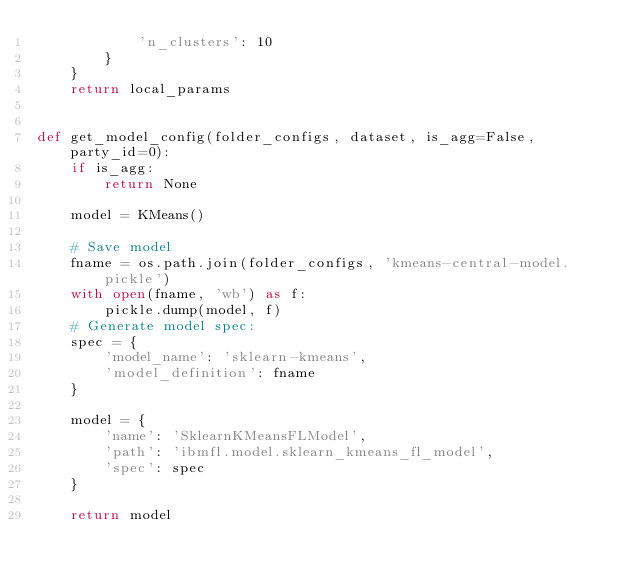<code> <loc_0><loc_0><loc_500><loc_500><_Python_>            'n_clusters': 10
        }
    }
    return local_params


def get_model_config(folder_configs, dataset, is_agg=False, party_id=0):
    if is_agg:
        return None

    model = KMeans()

    # Save model
    fname = os.path.join(folder_configs, 'kmeans-central-model.pickle')
    with open(fname, 'wb') as f:
        pickle.dump(model, f)
    # Generate model spec:
    spec = {
        'model_name': 'sklearn-kmeans',
        'model_definition': fname
    }

    model = {
        'name': 'SklearnKMeansFLModel',
        'path': 'ibmfl.model.sklearn_kmeans_fl_model',
        'spec': spec
    }

    return model</code> 